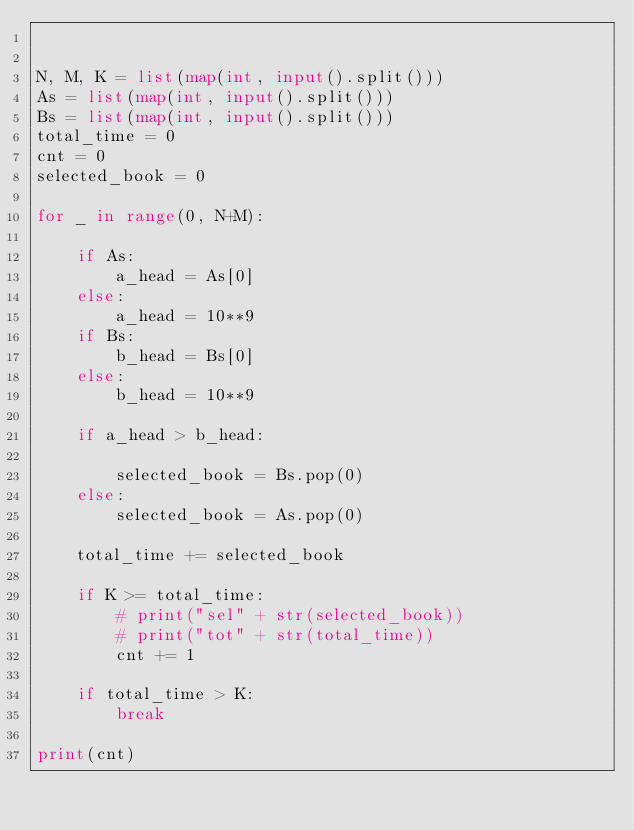Convert code to text. <code><loc_0><loc_0><loc_500><loc_500><_Python_>

N, M, K = list(map(int, input().split()))
As = list(map(int, input().split()))
Bs = list(map(int, input().split()))
total_time = 0
cnt = 0
selected_book = 0

for _ in range(0, N+M):

    if As:
        a_head = As[0]
    else:
        a_head = 10**9
    if Bs:
        b_head = Bs[0]
    else:
        b_head = 10**9

    if a_head > b_head:

        selected_book = Bs.pop(0)
    else:
        selected_book = As.pop(0)

    total_time += selected_book

    if K >= total_time:
        # print("sel" + str(selected_book))
        # print("tot" + str(total_time))
        cnt += 1

    if total_time > K:
        break

print(cnt)
</code> 